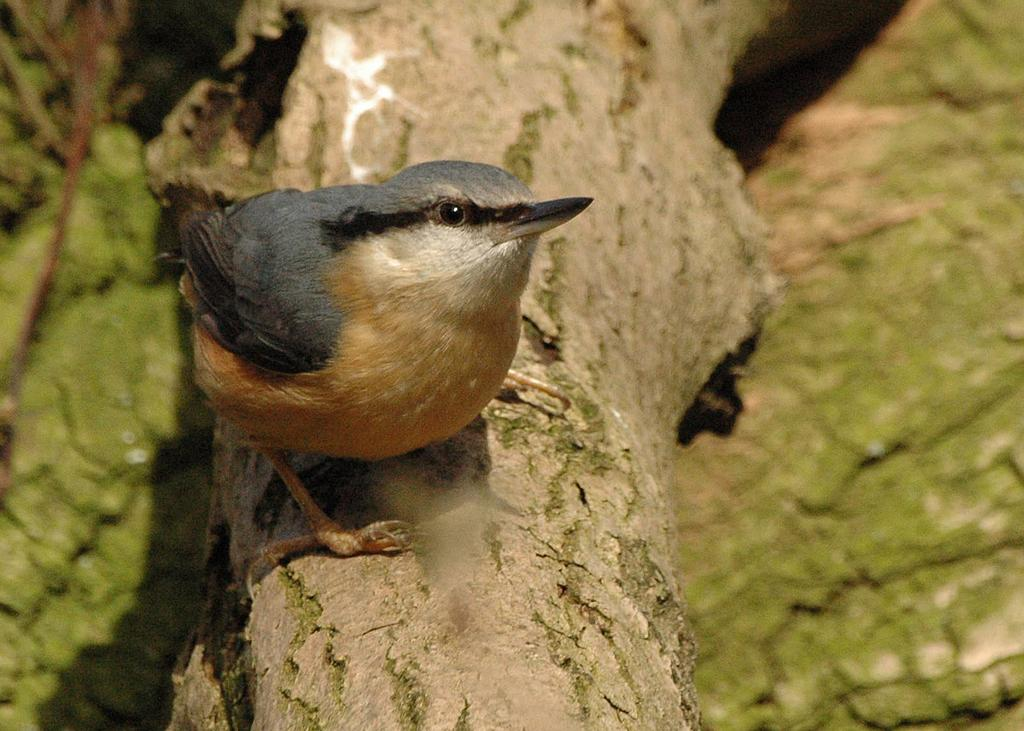What type of animal can be seen in the image? There is a bird in the image. Where is the bird located? The bird is on the bark of a tree. What is the topic of the argument taking place in the hall in the image? There is no hall or argument present in the image; it features a bird on the bark of a tree. 